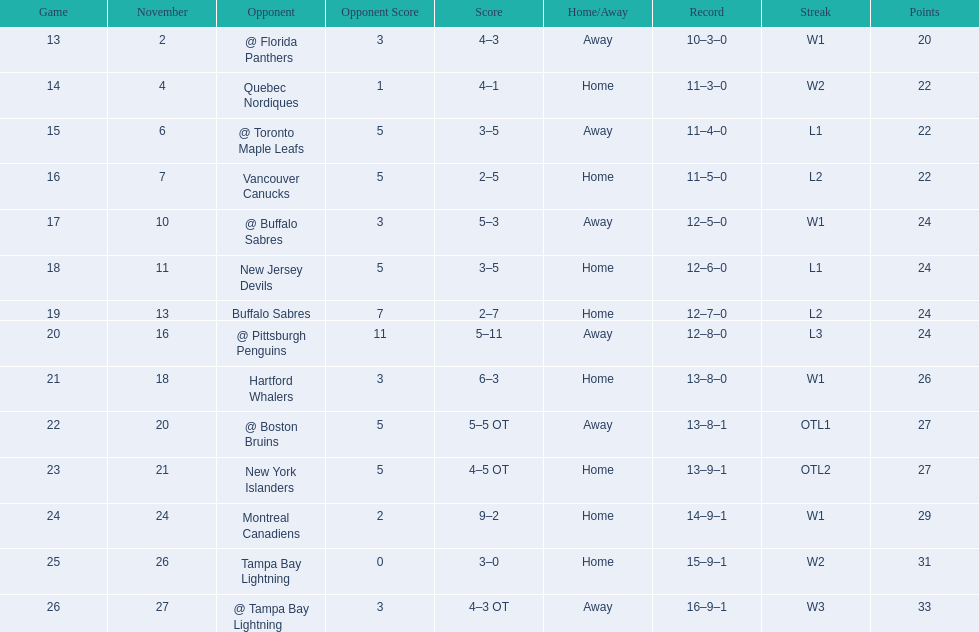What were the scores? @ Florida Panthers, 4–3, Quebec Nordiques, 4–1, @ Toronto Maple Leafs, 3–5, Vancouver Canucks, 2–5, @ Buffalo Sabres, 5–3, New Jersey Devils, 3–5, Buffalo Sabres, 2–7, @ Pittsburgh Penguins, 5–11, Hartford Whalers, 6–3, @ Boston Bruins, 5–5 OT, New York Islanders, 4–5 OT, Montreal Canadiens, 9–2, Tampa Bay Lightning, 3–0, @ Tampa Bay Lightning, 4–3 OT. What score was the closest? New York Islanders, 4–5 OT. What team had that score? New York Islanders. 